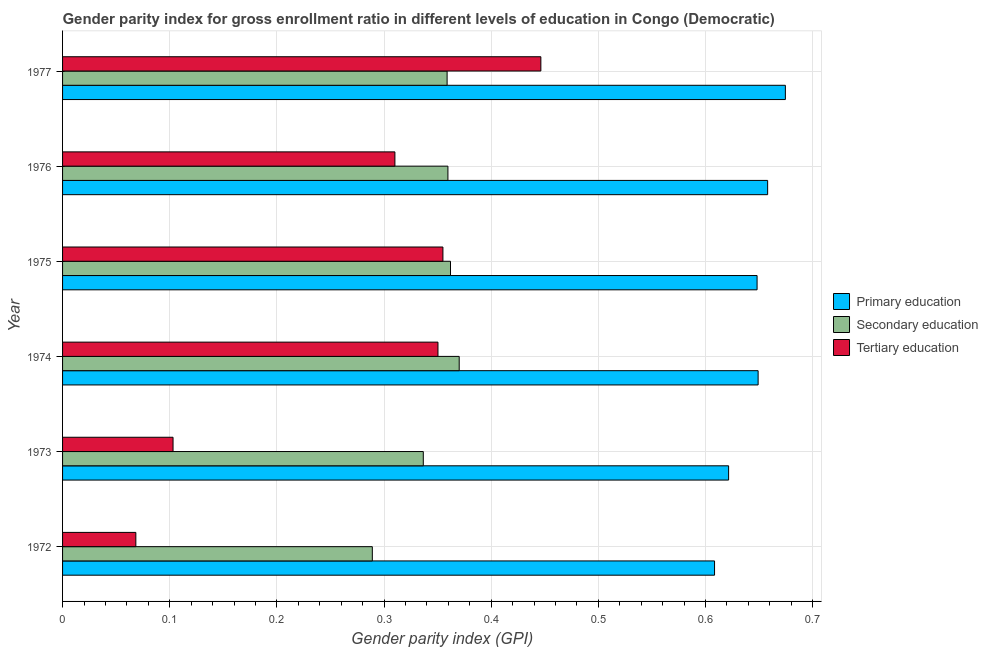How many groups of bars are there?
Give a very brief answer. 6. Are the number of bars on each tick of the Y-axis equal?
Make the answer very short. Yes. How many bars are there on the 4th tick from the top?
Make the answer very short. 3. How many bars are there on the 3rd tick from the bottom?
Provide a short and direct response. 3. What is the label of the 1st group of bars from the top?
Provide a short and direct response. 1977. What is the gender parity index in tertiary education in 1972?
Make the answer very short. 0.07. Across all years, what is the maximum gender parity index in tertiary education?
Your answer should be very brief. 0.45. Across all years, what is the minimum gender parity index in primary education?
Your answer should be very brief. 0.61. In which year was the gender parity index in secondary education maximum?
Make the answer very short. 1974. In which year was the gender parity index in secondary education minimum?
Provide a succinct answer. 1972. What is the total gender parity index in primary education in the graph?
Provide a succinct answer. 3.86. What is the difference between the gender parity index in primary education in 1974 and that in 1977?
Provide a succinct answer. -0.03. What is the difference between the gender parity index in primary education in 1976 and the gender parity index in tertiary education in 1977?
Offer a terse response. 0.21. What is the average gender parity index in secondary education per year?
Give a very brief answer. 0.35. In the year 1973, what is the difference between the gender parity index in tertiary education and gender parity index in secondary education?
Your answer should be very brief. -0.23. In how many years, is the gender parity index in primary education greater than 0.5 ?
Keep it short and to the point. 6. What is the ratio of the gender parity index in secondary education in 1976 to that in 1977?
Provide a succinct answer. 1. What is the difference between the highest and the second highest gender parity index in tertiary education?
Keep it short and to the point. 0.09. What is the difference between the highest and the lowest gender parity index in primary education?
Your response must be concise. 0.07. In how many years, is the gender parity index in tertiary education greater than the average gender parity index in tertiary education taken over all years?
Offer a terse response. 4. What does the 2nd bar from the top in 1974 represents?
Make the answer very short. Secondary education. What does the 3rd bar from the bottom in 1974 represents?
Offer a terse response. Tertiary education. How many years are there in the graph?
Keep it short and to the point. 6. Are the values on the major ticks of X-axis written in scientific E-notation?
Your answer should be very brief. No. How are the legend labels stacked?
Ensure brevity in your answer.  Vertical. What is the title of the graph?
Give a very brief answer. Gender parity index for gross enrollment ratio in different levels of education in Congo (Democratic). What is the label or title of the X-axis?
Provide a short and direct response. Gender parity index (GPI). What is the label or title of the Y-axis?
Provide a succinct answer. Year. What is the Gender parity index (GPI) of Primary education in 1972?
Ensure brevity in your answer.  0.61. What is the Gender parity index (GPI) in Secondary education in 1972?
Give a very brief answer. 0.29. What is the Gender parity index (GPI) of Tertiary education in 1972?
Provide a short and direct response. 0.07. What is the Gender parity index (GPI) of Primary education in 1973?
Make the answer very short. 0.62. What is the Gender parity index (GPI) of Secondary education in 1973?
Ensure brevity in your answer.  0.34. What is the Gender parity index (GPI) in Tertiary education in 1973?
Make the answer very short. 0.1. What is the Gender parity index (GPI) of Primary education in 1974?
Your answer should be compact. 0.65. What is the Gender parity index (GPI) of Secondary education in 1974?
Provide a short and direct response. 0.37. What is the Gender parity index (GPI) of Tertiary education in 1974?
Give a very brief answer. 0.35. What is the Gender parity index (GPI) in Primary education in 1975?
Your answer should be compact. 0.65. What is the Gender parity index (GPI) in Secondary education in 1975?
Your answer should be compact. 0.36. What is the Gender parity index (GPI) in Tertiary education in 1975?
Your response must be concise. 0.35. What is the Gender parity index (GPI) of Primary education in 1976?
Offer a terse response. 0.66. What is the Gender parity index (GPI) of Secondary education in 1976?
Your answer should be compact. 0.36. What is the Gender parity index (GPI) in Tertiary education in 1976?
Ensure brevity in your answer.  0.31. What is the Gender parity index (GPI) of Primary education in 1977?
Make the answer very short. 0.67. What is the Gender parity index (GPI) of Secondary education in 1977?
Keep it short and to the point. 0.36. What is the Gender parity index (GPI) in Tertiary education in 1977?
Offer a very short reply. 0.45. Across all years, what is the maximum Gender parity index (GPI) in Primary education?
Offer a very short reply. 0.67. Across all years, what is the maximum Gender parity index (GPI) of Secondary education?
Ensure brevity in your answer.  0.37. Across all years, what is the maximum Gender parity index (GPI) in Tertiary education?
Offer a very short reply. 0.45. Across all years, what is the minimum Gender parity index (GPI) in Primary education?
Offer a terse response. 0.61. Across all years, what is the minimum Gender parity index (GPI) of Secondary education?
Your answer should be very brief. 0.29. Across all years, what is the minimum Gender parity index (GPI) of Tertiary education?
Offer a very short reply. 0.07. What is the total Gender parity index (GPI) of Primary education in the graph?
Your answer should be very brief. 3.86. What is the total Gender parity index (GPI) of Secondary education in the graph?
Make the answer very short. 2.08. What is the total Gender parity index (GPI) in Tertiary education in the graph?
Keep it short and to the point. 1.63. What is the difference between the Gender parity index (GPI) in Primary education in 1972 and that in 1973?
Ensure brevity in your answer.  -0.01. What is the difference between the Gender parity index (GPI) of Secondary education in 1972 and that in 1973?
Make the answer very short. -0.05. What is the difference between the Gender parity index (GPI) in Tertiary education in 1972 and that in 1973?
Your answer should be compact. -0.03. What is the difference between the Gender parity index (GPI) of Primary education in 1972 and that in 1974?
Give a very brief answer. -0.04. What is the difference between the Gender parity index (GPI) of Secondary education in 1972 and that in 1974?
Ensure brevity in your answer.  -0.08. What is the difference between the Gender parity index (GPI) of Tertiary education in 1972 and that in 1974?
Your answer should be very brief. -0.28. What is the difference between the Gender parity index (GPI) of Primary education in 1972 and that in 1975?
Offer a very short reply. -0.04. What is the difference between the Gender parity index (GPI) in Secondary education in 1972 and that in 1975?
Make the answer very short. -0.07. What is the difference between the Gender parity index (GPI) of Tertiary education in 1972 and that in 1975?
Your response must be concise. -0.29. What is the difference between the Gender parity index (GPI) of Primary education in 1972 and that in 1976?
Keep it short and to the point. -0.05. What is the difference between the Gender parity index (GPI) in Secondary education in 1972 and that in 1976?
Give a very brief answer. -0.07. What is the difference between the Gender parity index (GPI) of Tertiary education in 1972 and that in 1976?
Ensure brevity in your answer.  -0.24. What is the difference between the Gender parity index (GPI) of Primary education in 1972 and that in 1977?
Offer a very short reply. -0.07. What is the difference between the Gender parity index (GPI) of Secondary education in 1972 and that in 1977?
Your answer should be very brief. -0.07. What is the difference between the Gender parity index (GPI) in Tertiary education in 1972 and that in 1977?
Give a very brief answer. -0.38. What is the difference between the Gender parity index (GPI) in Primary education in 1973 and that in 1974?
Provide a succinct answer. -0.03. What is the difference between the Gender parity index (GPI) in Secondary education in 1973 and that in 1974?
Your answer should be very brief. -0.03. What is the difference between the Gender parity index (GPI) in Tertiary education in 1973 and that in 1974?
Offer a terse response. -0.25. What is the difference between the Gender parity index (GPI) of Primary education in 1973 and that in 1975?
Provide a succinct answer. -0.03. What is the difference between the Gender parity index (GPI) in Secondary education in 1973 and that in 1975?
Offer a terse response. -0.03. What is the difference between the Gender parity index (GPI) in Tertiary education in 1973 and that in 1975?
Your answer should be very brief. -0.25. What is the difference between the Gender parity index (GPI) in Primary education in 1973 and that in 1976?
Offer a terse response. -0.04. What is the difference between the Gender parity index (GPI) of Secondary education in 1973 and that in 1976?
Provide a succinct answer. -0.02. What is the difference between the Gender parity index (GPI) in Tertiary education in 1973 and that in 1976?
Provide a succinct answer. -0.21. What is the difference between the Gender parity index (GPI) in Primary education in 1973 and that in 1977?
Keep it short and to the point. -0.05. What is the difference between the Gender parity index (GPI) in Secondary education in 1973 and that in 1977?
Provide a short and direct response. -0.02. What is the difference between the Gender parity index (GPI) of Tertiary education in 1973 and that in 1977?
Your answer should be compact. -0.34. What is the difference between the Gender parity index (GPI) of Primary education in 1974 and that in 1975?
Offer a very short reply. 0. What is the difference between the Gender parity index (GPI) of Secondary education in 1974 and that in 1975?
Your answer should be compact. 0.01. What is the difference between the Gender parity index (GPI) in Tertiary education in 1974 and that in 1975?
Ensure brevity in your answer.  -0. What is the difference between the Gender parity index (GPI) of Primary education in 1974 and that in 1976?
Offer a very short reply. -0.01. What is the difference between the Gender parity index (GPI) in Secondary education in 1974 and that in 1976?
Offer a very short reply. 0.01. What is the difference between the Gender parity index (GPI) in Tertiary education in 1974 and that in 1976?
Offer a terse response. 0.04. What is the difference between the Gender parity index (GPI) in Primary education in 1974 and that in 1977?
Provide a succinct answer. -0.03. What is the difference between the Gender parity index (GPI) in Secondary education in 1974 and that in 1977?
Make the answer very short. 0.01. What is the difference between the Gender parity index (GPI) in Tertiary education in 1974 and that in 1977?
Ensure brevity in your answer.  -0.1. What is the difference between the Gender parity index (GPI) of Primary education in 1975 and that in 1976?
Make the answer very short. -0.01. What is the difference between the Gender parity index (GPI) in Secondary education in 1975 and that in 1976?
Your answer should be compact. 0. What is the difference between the Gender parity index (GPI) in Tertiary education in 1975 and that in 1976?
Provide a succinct answer. 0.04. What is the difference between the Gender parity index (GPI) of Primary education in 1975 and that in 1977?
Your answer should be very brief. -0.03. What is the difference between the Gender parity index (GPI) in Secondary education in 1975 and that in 1977?
Your answer should be very brief. 0. What is the difference between the Gender parity index (GPI) of Tertiary education in 1975 and that in 1977?
Offer a terse response. -0.09. What is the difference between the Gender parity index (GPI) of Primary education in 1976 and that in 1977?
Your answer should be very brief. -0.02. What is the difference between the Gender parity index (GPI) in Secondary education in 1976 and that in 1977?
Offer a terse response. 0. What is the difference between the Gender parity index (GPI) of Tertiary education in 1976 and that in 1977?
Give a very brief answer. -0.14. What is the difference between the Gender parity index (GPI) of Primary education in 1972 and the Gender parity index (GPI) of Secondary education in 1973?
Keep it short and to the point. 0.27. What is the difference between the Gender parity index (GPI) in Primary education in 1972 and the Gender parity index (GPI) in Tertiary education in 1973?
Make the answer very short. 0.51. What is the difference between the Gender parity index (GPI) in Secondary education in 1972 and the Gender parity index (GPI) in Tertiary education in 1973?
Your answer should be compact. 0.19. What is the difference between the Gender parity index (GPI) in Primary education in 1972 and the Gender parity index (GPI) in Secondary education in 1974?
Make the answer very short. 0.24. What is the difference between the Gender parity index (GPI) in Primary education in 1972 and the Gender parity index (GPI) in Tertiary education in 1974?
Give a very brief answer. 0.26. What is the difference between the Gender parity index (GPI) of Secondary education in 1972 and the Gender parity index (GPI) of Tertiary education in 1974?
Provide a short and direct response. -0.06. What is the difference between the Gender parity index (GPI) in Primary education in 1972 and the Gender parity index (GPI) in Secondary education in 1975?
Provide a short and direct response. 0.25. What is the difference between the Gender parity index (GPI) in Primary education in 1972 and the Gender parity index (GPI) in Tertiary education in 1975?
Your response must be concise. 0.25. What is the difference between the Gender parity index (GPI) of Secondary education in 1972 and the Gender parity index (GPI) of Tertiary education in 1975?
Offer a very short reply. -0.07. What is the difference between the Gender parity index (GPI) of Primary education in 1972 and the Gender parity index (GPI) of Secondary education in 1976?
Ensure brevity in your answer.  0.25. What is the difference between the Gender parity index (GPI) of Primary education in 1972 and the Gender parity index (GPI) of Tertiary education in 1976?
Keep it short and to the point. 0.3. What is the difference between the Gender parity index (GPI) in Secondary education in 1972 and the Gender parity index (GPI) in Tertiary education in 1976?
Give a very brief answer. -0.02. What is the difference between the Gender parity index (GPI) in Primary education in 1972 and the Gender parity index (GPI) in Secondary education in 1977?
Ensure brevity in your answer.  0.25. What is the difference between the Gender parity index (GPI) of Primary education in 1972 and the Gender parity index (GPI) of Tertiary education in 1977?
Offer a terse response. 0.16. What is the difference between the Gender parity index (GPI) of Secondary education in 1972 and the Gender parity index (GPI) of Tertiary education in 1977?
Give a very brief answer. -0.16. What is the difference between the Gender parity index (GPI) in Primary education in 1973 and the Gender parity index (GPI) in Secondary education in 1974?
Provide a short and direct response. 0.25. What is the difference between the Gender parity index (GPI) of Primary education in 1973 and the Gender parity index (GPI) of Tertiary education in 1974?
Provide a succinct answer. 0.27. What is the difference between the Gender parity index (GPI) in Secondary education in 1973 and the Gender parity index (GPI) in Tertiary education in 1974?
Your answer should be very brief. -0.01. What is the difference between the Gender parity index (GPI) in Primary education in 1973 and the Gender parity index (GPI) in Secondary education in 1975?
Give a very brief answer. 0.26. What is the difference between the Gender parity index (GPI) in Primary education in 1973 and the Gender parity index (GPI) in Tertiary education in 1975?
Give a very brief answer. 0.27. What is the difference between the Gender parity index (GPI) in Secondary education in 1973 and the Gender parity index (GPI) in Tertiary education in 1975?
Offer a terse response. -0.02. What is the difference between the Gender parity index (GPI) in Primary education in 1973 and the Gender parity index (GPI) in Secondary education in 1976?
Provide a succinct answer. 0.26. What is the difference between the Gender parity index (GPI) in Primary education in 1973 and the Gender parity index (GPI) in Tertiary education in 1976?
Your answer should be compact. 0.31. What is the difference between the Gender parity index (GPI) of Secondary education in 1973 and the Gender parity index (GPI) of Tertiary education in 1976?
Keep it short and to the point. 0.03. What is the difference between the Gender parity index (GPI) in Primary education in 1973 and the Gender parity index (GPI) in Secondary education in 1977?
Keep it short and to the point. 0.26. What is the difference between the Gender parity index (GPI) of Primary education in 1973 and the Gender parity index (GPI) of Tertiary education in 1977?
Your response must be concise. 0.18. What is the difference between the Gender parity index (GPI) of Secondary education in 1973 and the Gender parity index (GPI) of Tertiary education in 1977?
Your answer should be very brief. -0.11. What is the difference between the Gender parity index (GPI) of Primary education in 1974 and the Gender parity index (GPI) of Secondary education in 1975?
Offer a terse response. 0.29. What is the difference between the Gender parity index (GPI) in Primary education in 1974 and the Gender parity index (GPI) in Tertiary education in 1975?
Your response must be concise. 0.29. What is the difference between the Gender parity index (GPI) in Secondary education in 1974 and the Gender parity index (GPI) in Tertiary education in 1975?
Keep it short and to the point. 0.02. What is the difference between the Gender parity index (GPI) in Primary education in 1974 and the Gender parity index (GPI) in Secondary education in 1976?
Provide a short and direct response. 0.29. What is the difference between the Gender parity index (GPI) in Primary education in 1974 and the Gender parity index (GPI) in Tertiary education in 1976?
Make the answer very short. 0.34. What is the difference between the Gender parity index (GPI) of Secondary education in 1974 and the Gender parity index (GPI) of Tertiary education in 1976?
Offer a very short reply. 0.06. What is the difference between the Gender parity index (GPI) in Primary education in 1974 and the Gender parity index (GPI) in Secondary education in 1977?
Keep it short and to the point. 0.29. What is the difference between the Gender parity index (GPI) of Primary education in 1974 and the Gender parity index (GPI) of Tertiary education in 1977?
Your response must be concise. 0.2. What is the difference between the Gender parity index (GPI) of Secondary education in 1974 and the Gender parity index (GPI) of Tertiary education in 1977?
Keep it short and to the point. -0.08. What is the difference between the Gender parity index (GPI) in Primary education in 1975 and the Gender parity index (GPI) in Secondary education in 1976?
Make the answer very short. 0.29. What is the difference between the Gender parity index (GPI) in Primary education in 1975 and the Gender parity index (GPI) in Tertiary education in 1976?
Keep it short and to the point. 0.34. What is the difference between the Gender parity index (GPI) in Secondary education in 1975 and the Gender parity index (GPI) in Tertiary education in 1976?
Your answer should be very brief. 0.05. What is the difference between the Gender parity index (GPI) of Primary education in 1975 and the Gender parity index (GPI) of Secondary education in 1977?
Ensure brevity in your answer.  0.29. What is the difference between the Gender parity index (GPI) in Primary education in 1975 and the Gender parity index (GPI) in Tertiary education in 1977?
Keep it short and to the point. 0.2. What is the difference between the Gender parity index (GPI) in Secondary education in 1975 and the Gender parity index (GPI) in Tertiary education in 1977?
Your answer should be very brief. -0.08. What is the difference between the Gender parity index (GPI) in Primary education in 1976 and the Gender parity index (GPI) in Secondary education in 1977?
Offer a very short reply. 0.3. What is the difference between the Gender parity index (GPI) of Primary education in 1976 and the Gender parity index (GPI) of Tertiary education in 1977?
Your answer should be compact. 0.21. What is the difference between the Gender parity index (GPI) of Secondary education in 1976 and the Gender parity index (GPI) of Tertiary education in 1977?
Keep it short and to the point. -0.09. What is the average Gender parity index (GPI) of Primary education per year?
Offer a very short reply. 0.64. What is the average Gender parity index (GPI) in Secondary education per year?
Your answer should be compact. 0.35. What is the average Gender parity index (GPI) of Tertiary education per year?
Provide a short and direct response. 0.27. In the year 1972, what is the difference between the Gender parity index (GPI) in Primary education and Gender parity index (GPI) in Secondary education?
Keep it short and to the point. 0.32. In the year 1972, what is the difference between the Gender parity index (GPI) of Primary education and Gender parity index (GPI) of Tertiary education?
Offer a very short reply. 0.54. In the year 1972, what is the difference between the Gender parity index (GPI) of Secondary education and Gender parity index (GPI) of Tertiary education?
Your answer should be compact. 0.22. In the year 1973, what is the difference between the Gender parity index (GPI) in Primary education and Gender parity index (GPI) in Secondary education?
Make the answer very short. 0.28. In the year 1973, what is the difference between the Gender parity index (GPI) of Primary education and Gender parity index (GPI) of Tertiary education?
Offer a very short reply. 0.52. In the year 1973, what is the difference between the Gender parity index (GPI) of Secondary education and Gender parity index (GPI) of Tertiary education?
Ensure brevity in your answer.  0.23. In the year 1974, what is the difference between the Gender parity index (GPI) in Primary education and Gender parity index (GPI) in Secondary education?
Provide a succinct answer. 0.28. In the year 1974, what is the difference between the Gender parity index (GPI) in Primary education and Gender parity index (GPI) in Tertiary education?
Give a very brief answer. 0.3. In the year 1974, what is the difference between the Gender parity index (GPI) in Secondary education and Gender parity index (GPI) in Tertiary education?
Your answer should be very brief. 0.02. In the year 1975, what is the difference between the Gender parity index (GPI) in Primary education and Gender parity index (GPI) in Secondary education?
Give a very brief answer. 0.29. In the year 1975, what is the difference between the Gender parity index (GPI) in Primary education and Gender parity index (GPI) in Tertiary education?
Your answer should be very brief. 0.29. In the year 1975, what is the difference between the Gender parity index (GPI) of Secondary education and Gender parity index (GPI) of Tertiary education?
Offer a terse response. 0.01. In the year 1976, what is the difference between the Gender parity index (GPI) in Primary education and Gender parity index (GPI) in Secondary education?
Give a very brief answer. 0.3. In the year 1976, what is the difference between the Gender parity index (GPI) in Primary education and Gender parity index (GPI) in Tertiary education?
Offer a terse response. 0.35. In the year 1976, what is the difference between the Gender parity index (GPI) in Secondary education and Gender parity index (GPI) in Tertiary education?
Your response must be concise. 0.05. In the year 1977, what is the difference between the Gender parity index (GPI) in Primary education and Gender parity index (GPI) in Secondary education?
Your answer should be compact. 0.32. In the year 1977, what is the difference between the Gender parity index (GPI) of Primary education and Gender parity index (GPI) of Tertiary education?
Provide a short and direct response. 0.23. In the year 1977, what is the difference between the Gender parity index (GPI) in Secondary education and Gender parity index (GPI) in Tertiary education?
Keep it short and to the point. -0.09. What is the ratio of the Gender parity index (GPI) of Primary education in 1972 to that in 1973?
Ensure brevity in your answer.  0.98. What is the ratio of the Gender parity index (GPI) in Secondary education in 1972 to that in 1973?
Ensure brevity in your answer.  0.86. What is the ratio of the Gender parity index (GPI) of Tertiary education in 1972 to that in 1973?
Provide a short and direct response. 0.66. What is the ratio of the Gender parity index (GPI) in Primary education in 1972 to that in 1974?
Keep it short and to the point. 0.94. What is the ratio of the Gender parity index (GPI) of Secondary education in 1972 to that in 1974?
Provide a short and direct response. 0.78. What is the ratio of the Gender parity index (GPI) in Tertiary education in 1972 to that in 1974?
Give a very brief answer. 0.2. What is the ratio of the Gender parity index (GPI) of Primary education in 1972 to that in 1975?
Ensure brevity in your answer.  0.94. What is the ratio of the Gender parity index (GPI) in Secondary education in 1972 to that in 1975?
Keep it short and to the point. 0.8. What is the ratio of the Gender parity index (GPI) of Tertiary education in 1972 to that in 1975?
Ensure brevity in your answer.  0.19. What is the ratio of the Gender parity index (GPI) of Primary education in 1972 to that in 1976?
Your answer should be very brief. 0.92. What is the ratio of the Gender parity index (GPI) of Secondary education in 1972 to that in 1976?
Ensure brevity in your answer.  0.8. What is the ratio of the Gender parity index (GPI) of Tertiary education in 1972 to that in 1976?
Offer a terse response. 0.22. What is the ratio of the Gender parity index (GPI) of Primary education in 1972 to that in 1977?
Make the answer very short. 0.9. What is the ratio of the Gender parity index (GPI) in Secondary education in 1972 to that in 1977?
Keep it short and to the point. 0.81. What is the ratio of the Gender parity index (GPI) in Tertiary education in 1972 to that in 1977?
Give a very brief answer. 0.15. What is the ratio of the Gender parity index (GPI) of Primary education in 1973 to that in 1974?
Give a very brief answer. 0.96. What is the ratio of the Gender parity index (GPI) of Secondary education in 1973 to that in 1974?
Your response must be concise. 0.91. What is the ratio of the Gender parity index (GPI) of Tertiary education in 1973 to that in 1974?
Provide a succinct answer. 0.29. What is the ratio of the Gender parity index (GPI) in Secondary education in 1973 to that in 1975?
Give a very brief answer. 0.93. What is the ratio of the Gender parity index (GPI) of Tertiary education in 1973 to that in 1975?
Provide a short and direct response. 0.29. What is the ratio of the Gender parity index (GPI) in Primary education in 1973 to that in 1976?
Give a very brief answer. 0.94. What is the ratio of the Gender parity index (GPI) of Secondary education in 1973 to that in 1976?
Provide a succinct answer. 0.94. What is the ratio of the Gender parity index (GPI) of Tertiary education in 1973 to that in 1976?
Provide a succinct answer. 0.33. What is the ratio of the Gender parity index (GPI) in Primary education in 1973 to that in 1977?
Provide a succinct answer. 0.92. What is the ratio of the Gender parity index (GPI) in Secondary education in 1973 to that in 1977?
Your answer should be compact. 0.94. What is the ratio of the Gender parity index (GPI) in Tertiary education in 1973 to that in 1977?
Make the answer very short. 0.23. What is the ratio of the Gender parity index (GPI) in Secondary education in 1974 to that in 1975?
Offer a very short reply. 1.02. What is the ratio of the Gender parity index (GPI) of Primary education in 1974 to that in 1976?
Give a very brief answer. 0.99. What is the ratio of the Gender parity index (GPI) in Secondary education in 1974 to that in 1976?
Keep it short and to the point. 1.03. What is the ratio of the Gender parity index (GPI) of Tertiary education in 1974 to that in 1976?
Offer a very short reply. 1.13. What is the ratio of the Gender parity index (GPI) in Primary education in 1974 to that in 1977?
Your response must be concise. 0.96. What is the ratio of the Gender parity index (GPI) in Secondary education in 1974 to that in 1977?
Your answer should be compact. 1.03. What is the ratio of the Gender parity index (GPI) of Tertiary education in 1974 to that in 1977?
Keep it short and to the point. 0.78. What is the ratio of the Gender parity index (GPI) of Primary education in 1975 to that in 1976?
Provide a succinct answer. 0.98. What is the ratio of the Gender parity index (GPI) of Tertiary education in 1975 to that in 1976?
Keep it short and to the point. 1.14. What is the ratio of the Gender parity index (GPI) of Primary education in 1975 to that in 1977?
Ensure brevity in your answer.  0.96. What is the ratio of the Gender parity index (GPI) in Secondary education in 1975 to that in 1977?
Offer a very short reply. 1.01. What is the ratio of the Gender parity index (GPI) in Tertiary education in 1975 to that in 1977?
Provide a succinct answer. 0.8. What is the ratio of the Gender parity index (GPI) of Primary education in 1976 to that in 1977?
Provide a short and direct response. 0.98. What is the ratio of the Gender parity index (GPI) in Secondary education in 1976 to that in 1977?
Make the answer very short. 1. What is the ratio of the Gender parity index (GPI) of Tertiary education in 1976 to that in 1977?
Your answer should be compact. 0.69. What is the difference between the highest and the second highest Gender parity index (GPI) in Primary education?
Your response must be concise. 0.02. What is the difference between the highest and the second highest Gender parity index (GPI) of Secondary education?
Your answer should be compact. 0.01. What is the difference between the highest and the second highest Gender parity index (GPI) in Tertiary education?
Your answer should be compact. 0.09. What is the difference between the highest and the lowest Gender parity index (GPI) in Primary education?
Your answer should be compact. 0.07. What is the difference between the highest and the lowest Gender parity index (GPI) in Secondary education?
Keep it short and to the point. 0.08. What is the difference between the highest and the lowest Gender parity index (GPI) in Tertiary education?
Your answer should be compact. 0.38. 